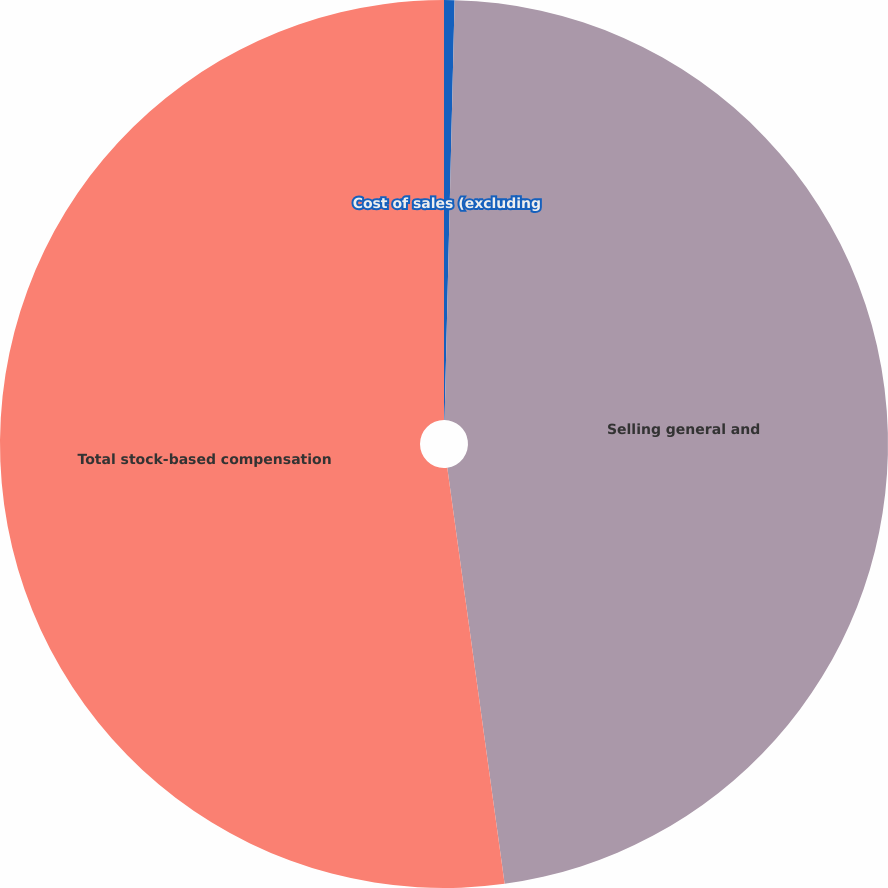Convert chart. <chart><loc_0><loc_0><loc_500><loc_500><pie_chart><fcel>Cost of sales (excluding<fcel>Selling general and<fcel>Total stock-based compensation<nl><fcel>0.38%<fcel>47.44%<fcel>52.18%<nl></chart> 